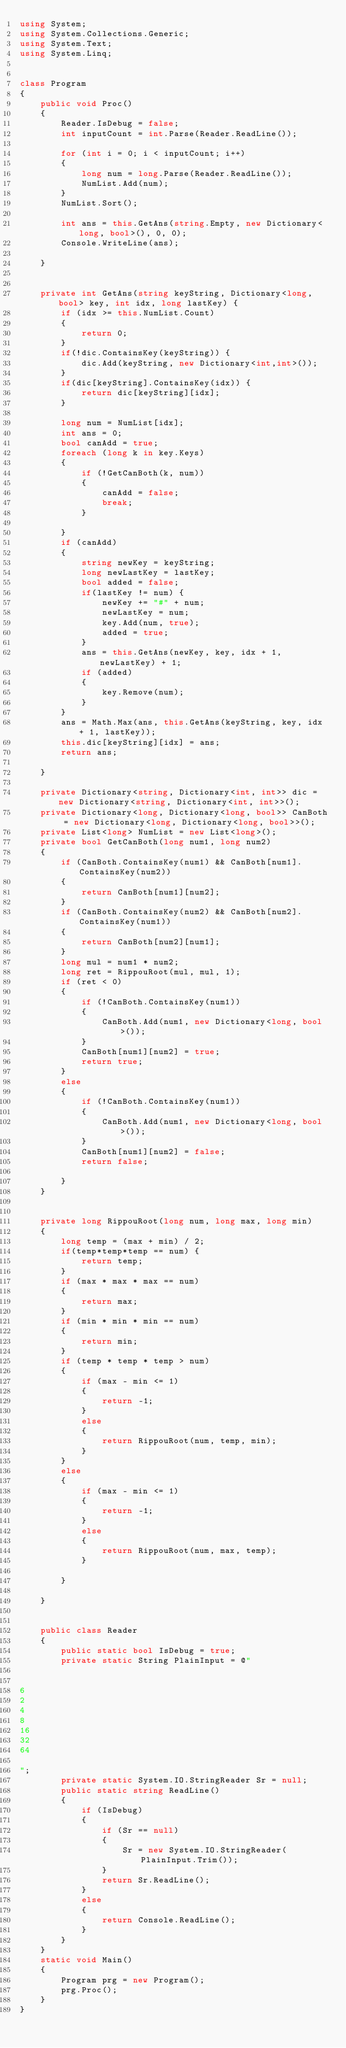<code> <loc_0><loc_0><loc_500><loc_500><_C#_>using System;
using System.Collections.Generic;
using System.Text;
using System.Linq;


class Program
{
    public void Proc()
    {
        Reader.IsDebug = false;
        int inputCount = int.Parse(Reader.ReadLine());

        for (int i = 0; i < inputCount; i++)
        {
            long num = long.Parse(Reader.ReadLine());
            NumList.Add(num);
        }
        NumList.Sort();

        int ans = this.GetAns(string.Empty, new Dictionary<long, bool>(), 0, 0);
        Console.WriteLine(ans);

    }


    private int GetAns(string keyString, Dictionary<long, bool> key, int idx, long lastKey) {
        if (idx >= this.NumList.Count)
        {
            return 0;
        }
        if(!dic.ContainsKey(keyString)) {
            dic.Add(keyString, new Dictionary<int,int>());
        }
        if(dic[keyString].ContainsKey(idx)) {
            return dic[keyString][idx];
        }

        long num = NumList[idx];
        int ans = 0;
        bool canAdd = true;
        foreach (long k in key.Keys)
        {
            if (!GetCanBoth(k, num))
            {
                canAdd = false;
                break;
            }

        }
        if (canAdd)
        {
            string newKey = keyString;
            long newLastKey = lastKey;
            bool added = false;
            if(lastKey != num) {
                newKey += "#" + num;
                newLastKey = num;
                key.Add(num, true);
                added = true;
            }
            ans = this.GetAns(newKey, key, idx + 1, newLastKey) + 1;
            if (added)
            {
                key.Remove(num);
            }
        }
        ans = Math.Max(ans, this.GetAns(keyString, key, idx + 1, lastKey));
        this.dic[keyString][idx] = ans;
        return ans;

    }

    private Dictionary<string, Dictionary<int, int>> dic = new Dictionary<string, Dictionary<int, int>>();
    private Dictionary<long, Dictionary<long, bool>> CanBoth = new Dictionary<long, Dictionary<long, bool>>();
    private List<long> NumList = new List<long>();
    private bool GetCanBoth(long num1, long num2)
    {
        if (CanBoth.ContainsKey(num1) && CanBoth[num1].ContainsKey(num2))
        {
            return CanBoth[num1][num2];
        }
        if (CanBoth.ContainsKey(num2) && CanBoth[num2].ContainsKey(num1))
        {
            return CanBoth[num2][num1];
        }
        long mul = num1 * num2;
        long ret = RippouRoot(mul, mul, 1);
        if (ret < 0)
        {
            if (!CanBoth.ContainsKey(num1))
            {
                CanBoth.Add(num1, new Dictionary<long, bool>());
            }
            CanBoth[num1][num2] = true;
            return true;
        }
        else
        {
            if (!CanBoth.ContainsKey(num1))
            {
                CanBoth.Add(num1, new Dictionary<long, bool>());
            }
            CanBoth[num1][num2] = false;
            return false;

        }
    }


    private long RippouRoot(long num, long max, long min)
    {
        long temp = (max + min) / 2;
        if(temp*temp*temp == num) {
            return temp;
        }
        if (max * max * max == num)
        {
            return max;
        }
        if (min * min * min == num)
        {
            return min;
        }
        if (temp * temp * temp > num)
        {
            if (max - min <= 1)
            {
                return -1;
            }
            else
            {
                return RippouRoot(num, temp, min);
            }
        }
        else
        {
            if (max - min <= 1)
            {
                return -1;
            }
            else
            {
                return RippouRoot(num, max, temp);
            }

        }
        
    }


    public class Reader
    {
        public static bool IsDebug = true;
        private static String PlainInput = @"


6
2
4
8
16
32
64

";
        private static System.IO.StringReader Sr = null;
        public static string ReadLine()
        {
            if (IsDebug)
            {
                if (Sr == null)
                {
                    Sr = new System.IO.StringReader(PlainInput.Trim());
                }
                return Sr.ReadLine();
            }
            else
            {
                return Console.ReadLine();
            }
        }
    }
    static void Main()
    {
        Program prg = new Program();
        prg.Proc();
    }
}</code> 